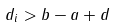<formula> <loc_0><loc_0><loc_500><loc_500>d _ { i } > b - a + d</formula> 